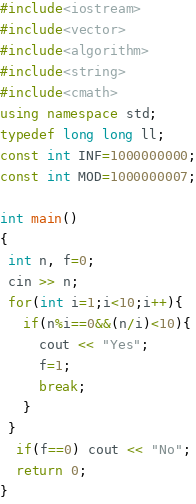<code> <loc_0><loc_0><loc_500><loc_500><_C++_>#include<iostream>
#include<vector>
#include<algorithm>
#include<string>
#include<cmath>
using namespace std;
typedef long long ll;
const int INF=1000000000;
const int MOD=1000000007;

int main()
{
 int n, f=0;
 cin >> n;
 for(int i=1;i<10;i++){
   if(n%i==0&&(n/i)<10){
     cout << "Yes";
     f=1;
     break;
   }
 }
  if(f==0) cout << "No";
  return 0;
}
</code> 